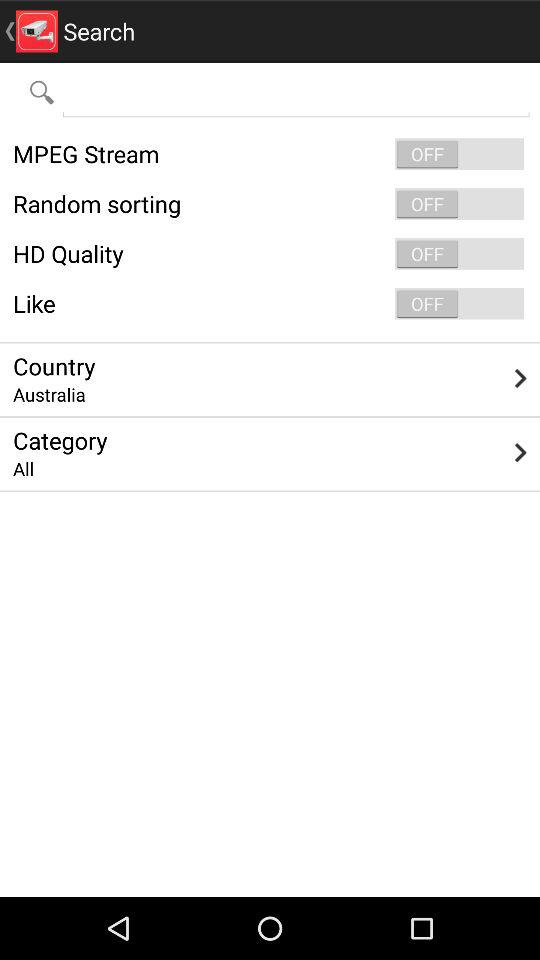What is the status of Like? The status is off. 